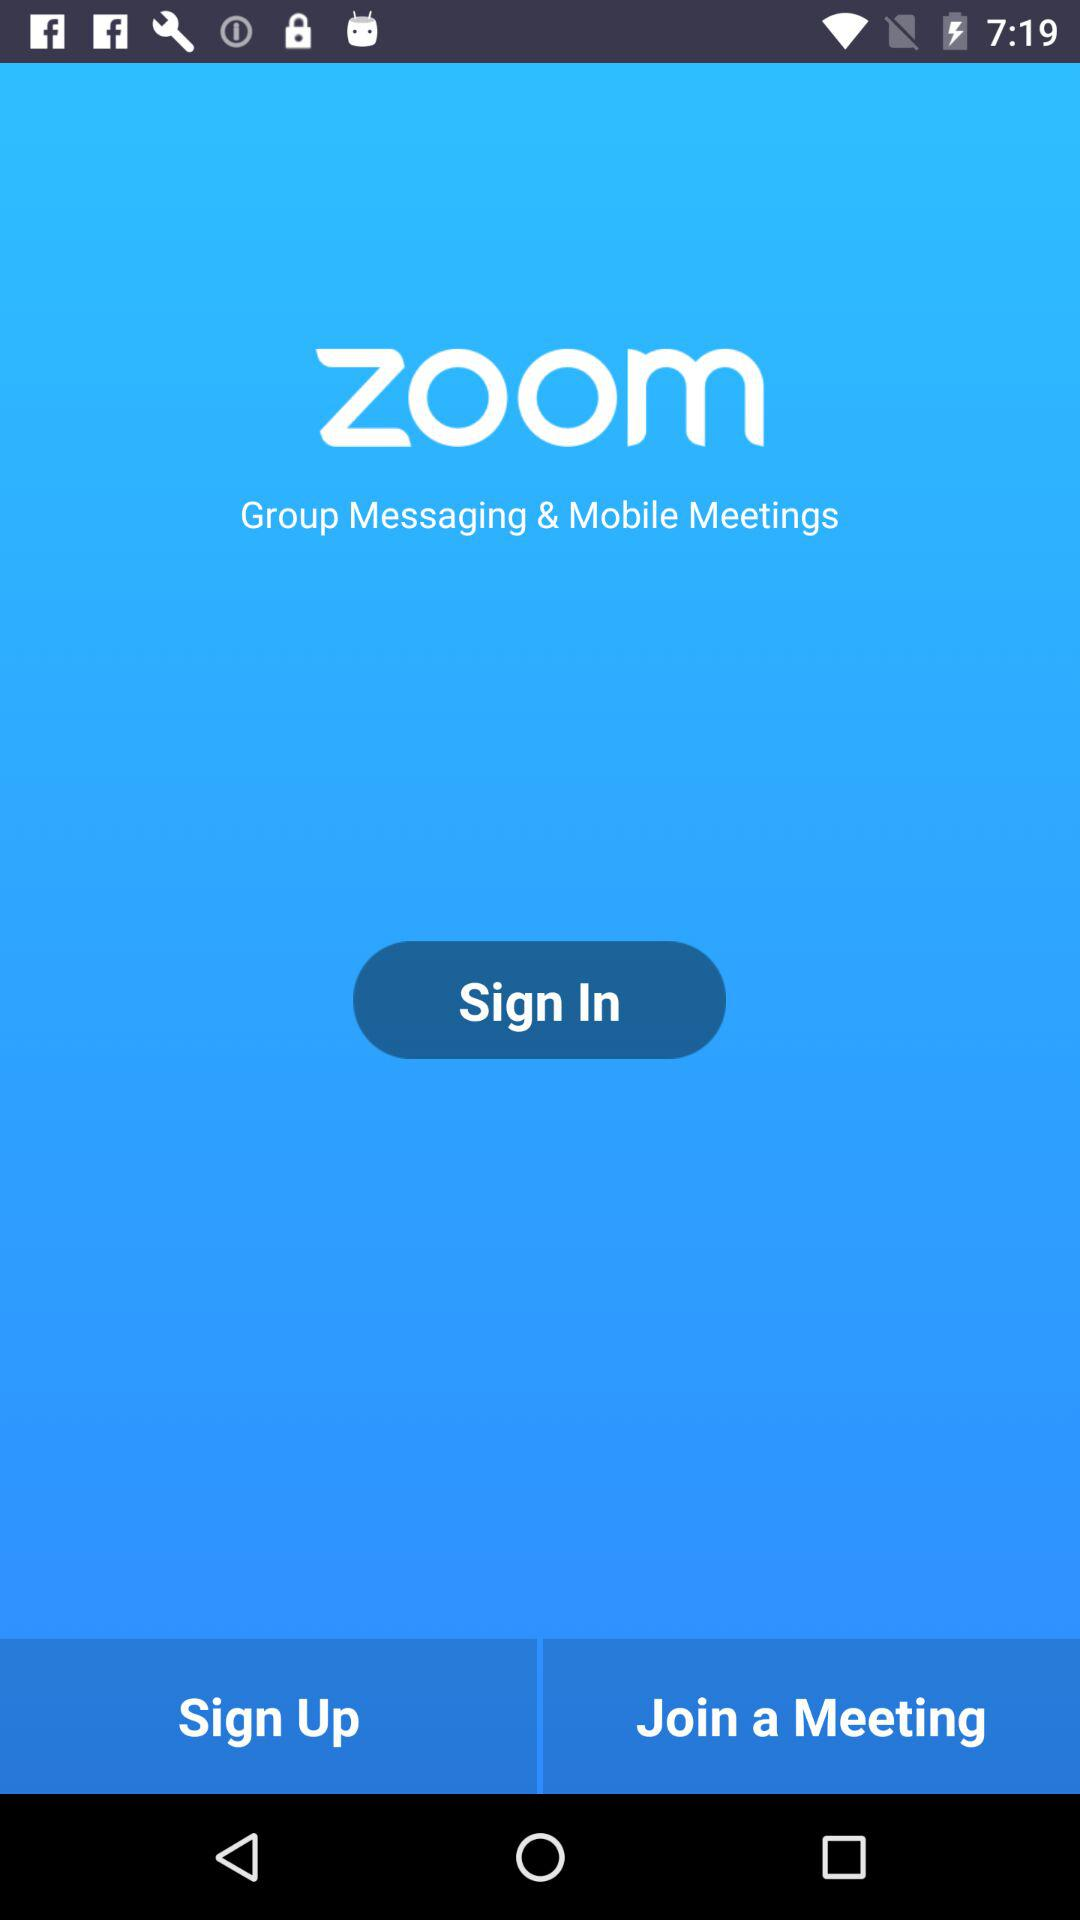What is the application name? The application name is "zoom". 